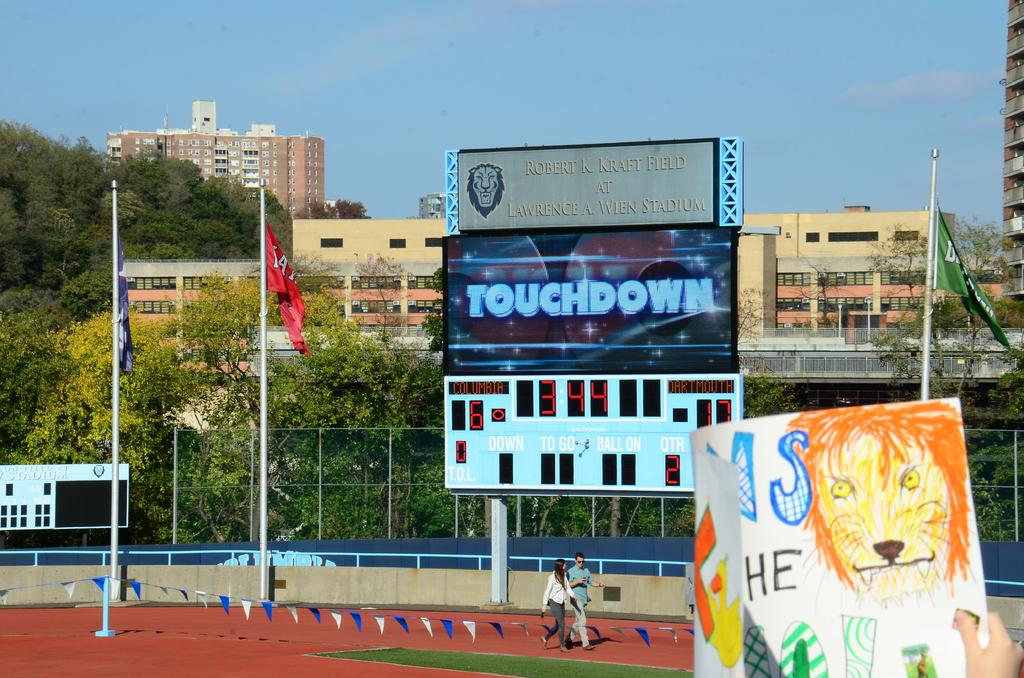<image>
Give a short and clear explanation of the subsequent image. Stadium that has a screen saying Touchdown and a couple walking in front of it. 